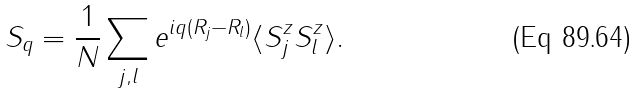<formula> <loc_0><loc_0><loc_500><loc_500>S _ { q } = \frac { 1 } { N } \sum _ { j , l } e ^ { i q ( R _ { j } - R _ { l } ) } \langle S ^ { z } _ { j } S ^ { z } _ { l } \rangle .</formula> 